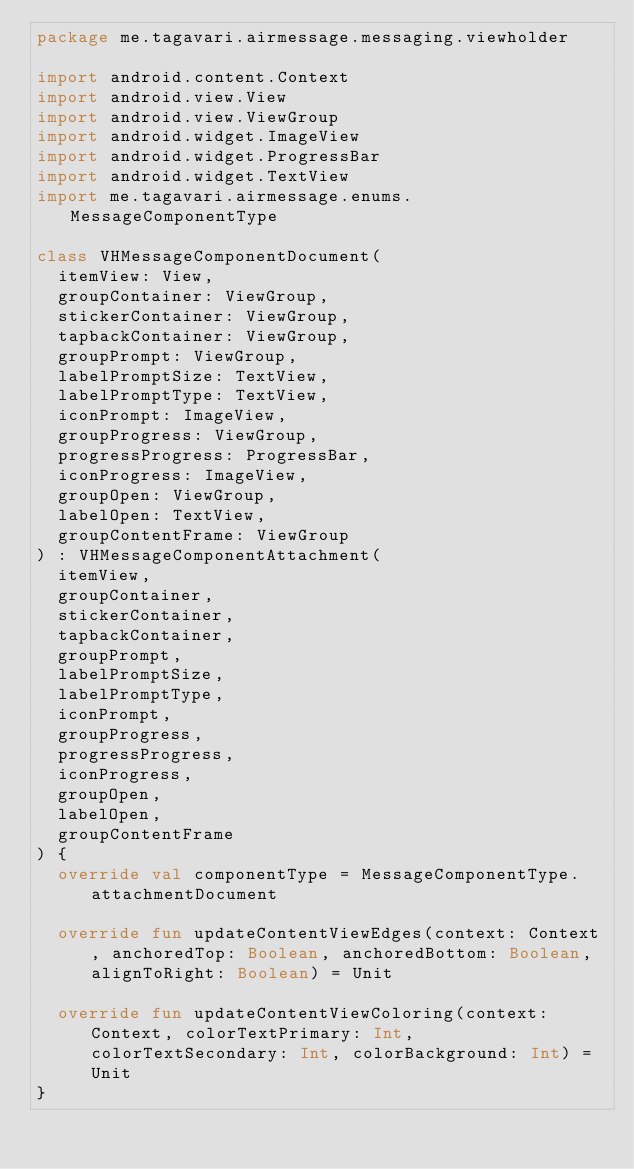<code> <loc_0><loc_0><loc_500><loc_500><_Kotlin_>package me.tagavari.airmessage.messaging.viewholder

import android.content.Context
import android.view.View
import android.view.ViewGroup
import android.widget.ImageView
import android.widget.ProgressBar
import android.widget.TextView
import me.tagavari.airmessage.enums.MessageComponentType

class VHMessageComponentDocument(
	itemView: View,
	groupContainer: ViewGroup,
	stickerContainer: ViewGroup,
	tapbackContainer: ViewGroup,
	groupPrompt: ViewGroup,
	labelPromptSize: TextView,
	labelPromptType: TextView,
	iconPrompt: ImageView,
	groupProgress: ViewGroup,
	progressProgress: ProgressBar,
	iconProgress: ImageView,
	groupOpen: ViewGroup,
	labelOpen: TextView,
	groupContentFrame: ViewGroup
) : VHMessageComponentAttachment(
	itemView,
	groupContainer,
	stickerContainer,
	tapbackContainer,
	groupPrompt,
	labelPromptSize,
	labelPromptType,
	iconPrompt,
	groupProgress,
	progressProgress,
	iconProgress,
	groupOpen,
	labelOpen,
	groupContentFrame
) {
	override val componentType = MessageComponentType.attachmentDocument
	
	override fun updateContentViewEdges(context: Context, anchoredTop: Boolean, anchoredBottom: Boolean, alignToRight: Boolean) = Unit
	
	override fun updateContentViewColoring(context: Context, colorTextPrimary: Int, colorTextSecondary: Int, colorBackground: Int) = Unit
}</code> 